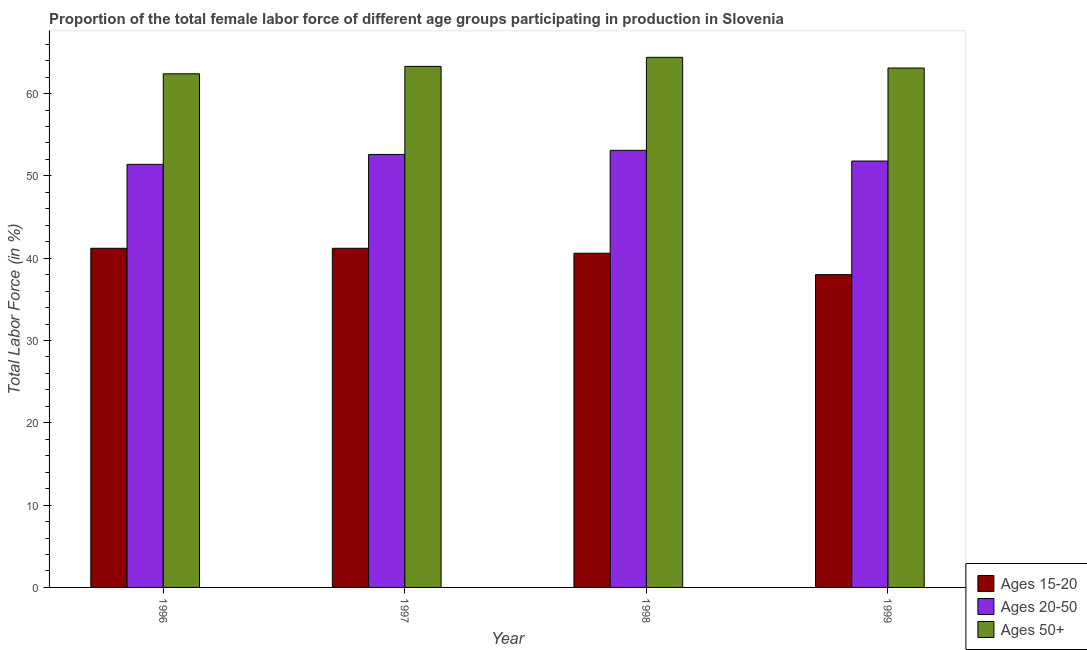Are the number of bars per tick equal to the number of legend labels?
Offer a very short reply. Yes. How many bars are there on the 4th tick from the left?
Make the answer very short. 3. What is the label of the 3rd group of bars from the left?
Ensure brevity in your answer.  1998. In how many cases, is the number of bars for a given year not equal to the number of legend labels?
Your response must be concise. 0. What is the percentage of female labor force within the age group 15-20 in 1997?
Give a very brief answer. 41.2. Across all years, what is the maximum percentage of female labor force within the age group 15-20?
Provide a short and direct response. 41.2. Across all years, what is the minimum percentage of female labor force within the age group 20-50?
Provide a short and direct response. 51.4. In which year was the percentage of female labor force within the age group 15-20 minimum?
Offer a terse response. 1999. What is the total percentage of female labor force within the age group 15-20 in the graph?
Provide a short and direct response. 161. What is the difference between the percentage of female labor force within the age group 20-50 in 1997 and that in 1999?
Make the answer very short. 0.8. What is the difference between the percentage of female labor force within the age group 20-50 in 1996 and the percentage of female labor force within the age group 15-20 in 1998?
Ensure brevity in your answer.  -1.7. What is the average percentage of female labor force within the age group 15-20 per year?
Provide a short and direct response. 40.25. In how many years, is the percentage of female labor force within the age group 20-50 greater than 50 %?
Provide a succinct answer. 4. What is the ratio of the percentage of female labor force above age 50 in 1997 to that in 1999?
Your answer should be compact. 1. Is the percentage of female labor force above age 50 in 1996 less than that in 1998?
Your answer should be compact. Yes. What is the difference between the highest and the second highest percentage of female labor force within the age group 20-50?
Ensure brevity in your answer.  0.5. What is the difference between the highest and the lowest percentage of female labor force within the age group 20-50?
Make the answer very short. 1.7. Is the sum of the percentage of female labor force within the age group 20-50 in 1996 and 1998 greater than the maximum percentage of female labor force above age 50 across all years?
Make the answer very short. Yes. What does the 1st bar from the left in 1998 represents?
Give a very brief answer. Ages 15-20. What does the 1st bar from the right in 1999 represents?
Your response must be concise. Ages 50+. How many bars are there?
Keep it short and to the point. 12. Are all the bars in the graph horizontal?
Ensure brevity in your answer.  No. How many years are there in the graph?
Keep it short and to the point. 4. What is the difference between two consecutive major ticks on the Y-axis?
Give a very brief answer. 10. Are the values on the major ticks of Y-axis written in scientific E-notation?
Offer a terse response. No. Does the graph contain any zero values?
Keep it short and to the point. No. Does the graph contain grids?
Ensure brevity in your answer.  No. Where does the legend appear in the graph?
Your response must be concise. Bottom right. How are the legend labels stacked?
Make the answer very short. Vertical. What is the title of the graph?
Your answer should be very brief. Proportion of the total female labor force of different age groups participating in production in Slovenia. Does "Non-communicable diseases" appear as one of the legend labels in the graph?
Offer a very short reply. No. What is the label or title of the X-axis?
Your response must be concise. Year. What is the label or title of the Y-axis?
Ensure brevity in your answer.  Total Labor Force (in %). What is the Total Labor Force (in %) in Ages 15-20 in 1996?
Offer a terse response. 41.2. What is the Total Labor Force (in %) of Ages 20-50 in 1996?
Provide a succinct answer. 51.4. What is the Total Labor Force (in %) in Ages 50+ in 1996?
Ensure brevity in your answer.  62.4. What is the Total Labor Force (in %) in Ages 15-20 in 1997?
Offer a very short reply. 41.2. What is the Total Labor Force (in %) of Ages 20-50 in 1997?
Ensure brevity in your answer.  52.6. What is the Total Labor Force (in %) of Ages 50+ in 1997?
Your answer should be compact. 63.3. What is the Total Labor Force (in %) in Ages 15-20 in 1998?
Provide a short and direct response. 40.6. What is the Total Labor Force (in %) of Ages 20-50 in 1998?
Keep it short and to the point. 53.1. What is the Total Labor Force (in %) in Ages 50+ in 1998?
Offer a very short reply. 64.4. What is the Total Labor Force (in %) in Ages 15-20 in 1999?
Provide a succinct answer. 38. What is the Total Labor Force (in %) of Ages 20-50 in 1999?
Your answer should be very brief. 51.8. What is the Total Labor Force (in %) in Ages 50+ in 1999?
Make the answer very short. 63.1. Across all years, what is the maximum Total Labor Force (in %) of Ages 15-20?
Make the answer very short. 41.2. Across all years, what is the maximum Total Labor Force (in %) in Ages 20-50?
Provide a short and direct response. 53.1. Across all years, what is the maximum Total Labor Force (in %) of Ages 50+?
Offer a very short reply. 64.4. Across all years, what is the minimum Total Labor Force (in %) of Ages 20-50?
Your answer should be compact. 51.4. Across all years, what is the minimum Total Labor Force (in %) of Ages 50+?
Give a very brief answer. 62.4. What is the total Total Labor Force (in %) in Ages 15-20 in the graph?
Your answer should be compact. 161. What is the total Total Labor Force (in %) in Ages 20-50 in the graph?
Your answer should be compact. 208.9. What is the total Total Labor Force (in %) of Ages 50+ in the graph?
Keep it short and to the point. 253.2. What is the difference between the Total Labor Force (in %) of Ages 15-20 in 1996 and that in 1998?
Give a very brief answer. 0.6. What is the difference between the Total Labor Force (in %) in Ages 15-20 in 1996 and that in 1999?
Give a very brief answer. 3.2. What is the difference between the Total Labor Force (in %) in Ages 20-50 in 1996 and that in 1999?
Your answer should be compact. -0.4. What is the difference between the Total Labor Force (in %) of Ages 15-20 in 1997 and that in 1998?
Make the answer very short. 0.6. What is the difference between the Total Labor Force (in %) in Ages 20-50 in 1997 and that in 1998?
Offer a terse response. -0.5. What is the difference between the Total Labor Force (in %) in Ages 15-20 in 1997 and that in 1999?
Keep it short and to the point. 3.2. What is the difference between the Total Labor Force (in %) in Ages 20-50 in 1997 and that in 1999?
Ensure brevity in your answer.  0.8. What is the difference between the Total Labor Force (in %) in Ages 15-20 in 1998 and that in 1999?
Offer a very short reply. 2.6. What is the difference between the Total Labor Force (in %) of Ages 20-50 in 1998 and that in 1999?
Offer a terse response. 1.3. What is the difference between the Total Labor Force (in %) in Ages 15-20 in 1996 and the Total Labor Force (in %) in Ages 20-50 in 1997?
Your response must be concise. -11.4. What is the difference between the Total Labor Force (in %) of Ages 15-20 in 1996 and the Total Labor Force (in %) of Ages 50+ in 1997?
Your answer should be very brief. -22.1. What is the difference between the Total Labor Force (in %) in Ages 20-50 in 1996 and the Total Labor Force (in %) in Ages 50+ in 1997?
Your answer should be very brief. -11.9. What is the difference between the Total Labor Force (in %) in Ages 15-20 in 1996 and the Total Labor Force (in %) in Ages 50+ in 1998?
Provide a short and direct response. -23.2. What is the difference between the Total Labor Force (in %) of Ages 20-50 in 1996 and the Total Labor Force (in %) of Ages 50+ in 1998?
Your response must be concise. -13. What is the difference between the Total Labor Force (in %) of Ages 15-20 in 1996 and the Total Labor Force (in %) of Ages 50+ in 1999?
Keep it short and to the point. -21.9. What is the difference between the Total Labor Force (in %) in Ages 20-50 in 1996 and the Total Labor Force (in %) in Ages 50+ in 1999?
Give a very brief answer. -11.7. What is the difference between the Total Labor Force (in %) in Ages 15-20 in 1997 and the Total Labor Force (in %) in Ages 50+ in 1998?
Provide a succinct answer. -23.2. What is the difference between the Total Labor Force (in %) of Ages 15-20 in 1997 and the Total Labor Force (in %) of Ages 50+ in 1999?
Keep it short and to the point. -21.9. What is the difference between the Total Labor Force (in %) of Ages 20-50 in 1997 and the Total Labor Force (in %) of Ages 50+ in 1999?
Your answer should be compact. -10.5. What is the difference between the Total Labor Force (in %) in Ages 15-20 in 1998 and the Total Labor Force (in %) in Ages 50+ in 1999?
Provide a succinct answer. -22.5. What is the difference between the Total Labor Force (in %) of Ages 20-50 in 1998 and the Total Labor Force (in %) of Ages 50+ in 1999?
Give a very brief answer. -10. What is the average Total Labor Force (in %) in Ages 15-20 per year?
Your response must be concise. 40.25. What is the average Total Labor Force (in %) of Ages 20-50 per year?
Make the answer very short. 52.23. What is the average Total Labor Force (in %) of Ages 50+ per year?
Give a very brief answer. 63.3. In the year 1996, what is the difference between the Total Labor Force (in %) of Ages 15-20 and Total Labor Force (in %) of Ages 20-50?
Provide a succinct answer. -10.2. In the year 1996, what is the difference between the Total Labor Force (in %) in Ages 15-20 and Total Labor Force (in %) in Ages 50+?
Offer a terse response. -21.2. In the year 1997, what is the difference between the Total Labor Force (in %) in Ages 15-20 and Total Labor Force (in %) in Ages 20-50?
Offer a very short reply. -11.4. In the year 1997, what is the difference between the Total Labor Force (in %) of Ages 15-20 and Total Labor Force (in %) of Ages 50+?
Your answer should be compact. -22.1. In the year 1998, what is the difference between the Total Labor Force (in %) of Ages 15-20 and Total Labor Force (in %) of Ages 20-50?
Offer a terse response. -12.5. In the year 1998, what is the difference between the Total Labor Force (in %) in Ages 15-20 and Total Labor Force (in %) in Ages 50+?
Your answer should be very brief. -23.8. In the year 1998, what is the difference between the Total Labor Force (in %) of Ages 20-50 and Total Labor Force (in %) of Ages 50+?
Offer a terse response. -11.3. In the year 1999, what is the difference between the Total Labor Force (in %) of Ages 15-20 and Total Labor Force (in %) of Ages 20-50?
Make the answer very short. -13.8. In the year 1999, what is the difference between the Total Labor Force (in %) of Ages 15-20 and Total Labor Force (in %) of Ages 50+?
Ensure brevity in your answer.  -25.1. In the year 1999, what is the difference between the Total Labor Force (in %) of Ages 20-50 and Total Labor Force (in %) of Ages 50+?
Offer a terse response. -11.3. What is the ratio of the Total Labor Force (in %) of Ages 20-50 in 1996 to that in 1997?
Provide a succinct answer. 0.98. What is the ratio of the Total Labor Force (in %) of Ages 50+ in 1996 to that in 1997?
Provide a succinct answer. 0.99. What is the ratio of the Total Labor Force (in %) of Ages 15-20 in 1996 to that in 1998?
Your answer should be very brief. 1.01. What is the ratio of the Total Labor Force (in %) in Ages 50+ in 1996 to that in 1998?
Keep it short and to the point. 0.97. What is the ratio of the Total Labor Force (in %) in Ages 15-20 in 1996 to that in 1999?
Provide a short and direct response. 1.08. What is the ratio of the Total Labor Force (in %) of Ages 50+ in 1996 to that in 1999?
Keep it short and to the point. 0.99. What is the ratio of the Total Labor Force (in %) of Ages 15-20 in 1997 to that in 1998?
Provide a succinct answer. 1.01. What is the ratio of the Total Labor Force (in %) of Ages 20-50 in 1997 to that in 1998?
Provide a succinct answer. 0.99. What is the ratio of the Total Labor Force (in %) in Ages 50+ in 1997 to that in 1998?
Make the answer very short. 0.98. What is the ratio of the Total Labor Force (in %) in Ages 15-20 in 1997 to that in 1999?
Make the answer very short. 1.08. What is the ratio of the Total Labor Force (in %) of Ages 20-50 in 1997 to that in 1999?
Your response must be concise. 1.02. What is the ratio of the Total Labor Force (in %) in Ages 15-20 in 1998 to that in 1999?
Your answer should be very brief. 1.07. What is the ratio of the Total Labor Force (in %) of Ages 20-50 in 1998 to that in 1999?
Keep it short and to the point. 1.03. What is the ratio of the Total Labor Force (in %) in Ages 50+ in 1998 to that in 1999?
Make the answer very short. 1.02. What is the difference between the highest and the second highest Total Labor Force (in %) of Ages 15-20?
Give a very brief answer. 0. What is the difference between the highest and the lowest Total Labor Force (in %) in Ages 15-20?
Provide a succinct answer. 3.2. 